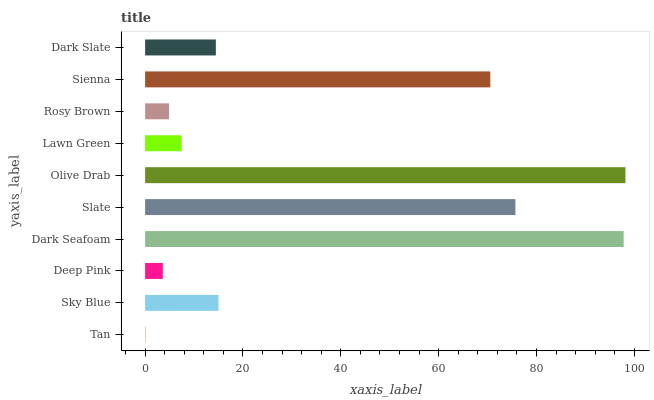Is Tan the minimum?
Answer yes or no. Yes. Is Olive Drab the maximum?
Answer yes or no. Yes. Is Sky Blue the minimum?
Answer yes or no. No. Is Sky Blue the maximum?
Answer yes or no. No. Is Sky Blue greater than Tan?
Answer yes or no. Yes. Is Tan less than Sky Blue?
Answer yes or no. Yes. Is Tan greater than Sky Blue?
Answer yes or no. No. Is Sky Blue less than Tan?
Answer yes or no. No. Is Sky Blue the high median?
Answer yes or no. Yes. Is Dark Slate the low median?
Answer yes or no. Yes. Is Dark Slate the high median?
Answer yes or no. No. Is Lawn Green the low median?
Answer yes or no. No. 